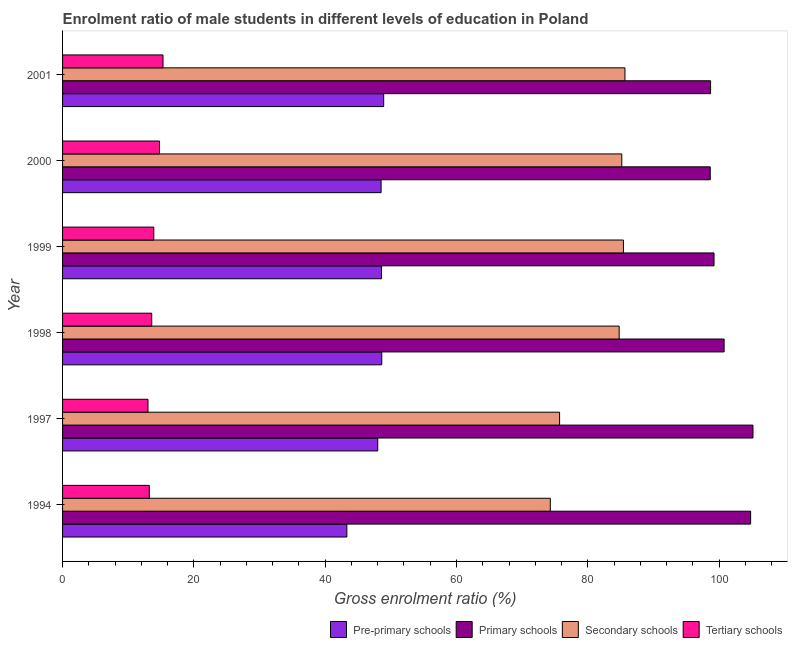How many different coloured bars are there?
Offer a very short reply. 4. How many groups of bars are there?
Your response must be concise. 6. Are the number of bars per tick equal to the number of legend labels?
Provide a short and direct response. Yes. How many bars are there on the 1st tick from the top?
Your answer should be very brief. 4. In how many cases, is the number of bars for a given year not equal to the number of legend labels?
Your answer should be very brief. 0. What is the gross enrolment ratio(female) in tertiary schools in 1998?
Provide a short and direct response. 13.58. Across all years, what is the maximum gross enrolment ratio(female) in tertiary schools?
Keep it short and to the point. 15.3. Across all years, what is the minimum gross enrolment ratio(female) in tertiary schools?
Provide a succinct answer. 13.01. What is the total gross enrolment ratio(female) in secondary schools in the graph?
Offer a very short reply. 491.03. What is the difference between the gross enrolment ratio(female) in primary schools in 2000 and that in 2001?
Offer a terse response. -0.05. What is the difference between the gross enrolment ratio(female) in tertiary schools in 1997 and the gross enrolment ratio(female) in secondary schools in 1994?
Keep it short and to the point. -61.28. What is the average gross enrolment ratio(female) in primary schools per year?
Offer a terse response. 101.22. In the year 2001, what is the difference between the gross enrolment ratio(female) in pre-primary schools and gross enrolment ratio(female) in tertiary schools?
Ensure brevity in your answer.  33.61. Is the difference between the gross enrolment ratio(female) in pre-primary schools in 1999 and 2000 greater than the difference between the gross enrolment ratio(female) in secondary schools in 1999 and 2000?
Offer a terse response. No. What is the difference between the highest and the second highest gross enrolment ratio(female) in pre-primary schools?
Your response must be concise. 0.29. What is the difference between the highest and the lowest gross enrolment ratio(female) in secondary schools?
Provide a succinct answer. 11.37. In how many years, is the gross enrolment ratio(female) in pre-primary schools greater than the average gross enrolment ratio(female) in pre-primary schools taken over all years?
Provide a succinct answer. 5. Is the sum of the gross enrolment ratio(female) in tertiary schools in 1994 and 1999 greater than the maximum gross enrolment ratio(female) in pre-primary schools across all years?
Offer a very short reply. No. Is it the case that in every year, the sum of the gross enrolment ratio(female) in tertiary schools and gross enrolment ratio(female) in primary schools is greater than the sum of gross enrolment ratio(female) in pre-primary schools and gross enrolment ratio(female) in secondary schools?
Offer a very short reply. No. What does the 4th bar from the top in 2000 represents?
Provide a succinct answer. Pre-primary schools. What does the 2nd bar from the bottom in 2001 represents?
Give a very brief answer. Primary schools. Where does the legend appear in the graph?
Make the answer very short. Bottom right. How many legend labels are there?
Your answer should be compact. 4. How are the legend labels stacked?
Give a very brief answer. Horizontal. What is the title of the graph?
Provide a short and direct response. Enrolment ratio of male students in different levels of education in Poland. Does "Offering training" appear as one of the legend labels in the graph?
Offer a very short reply. No. What is the label or title of the X-axis?
Make the answer very short. Gross enrolment ratio (%). What is the label or title of the Y-axis?
Offer a terse response. Year. What is the Gross enrolment ratio (%) of Pre-primary schools in 1994?
Offer a very short reply. 43.3. What is the Gross enrolment ratio (%) in Primary schools in 1994?
Make the answer very short. 104.8. What is the Gross enrolment ratio (%) in Secondary schools in 1994?
Offer a terse response. 74.29. What is the Gross enrolment ratio (%) in Tertiary schools in 1994?
Offer a terse response. 13.21. What is the Gross enrolment ratio (%) in Pre-primary schools in 1997?
Your response must be concise. 48. What is the Gross enrolment ratio (%) of Primary schools in 1997?
Make the answer very short. 105.16. What is the Gross enrolment ratio (%) of Secondary schools in 1997?
Give a very brief answer. 75.7. What is the Gross enrolment ratio (%) in Tertiary schools in 1997?
Provide a succinct answer. 13.01. What is the Gross enrolment ratio (%) in Pre-primary schools in 1998?
Your answer should be very brief. 48.62. What is the Gross enrolment ratio (%) in Primary schools in 1998?
Make the answer very short. 100.76. What is the Gross enrolment ratio (%) in Secondary schools in 1998?
Ensure brevity in your answer.  84.78. What is the Gross enrolment ratio (%) of Tertiary schools in 1998?
Ensure brevity in your answer.  13.58. What is the Gross enrolment ratio (%) of Pre-primary schools in 1999?
Offer a terse response. 48.58. What is the Gross enrolment ratio (%) of Primary schools in 1999?
Keep it short and to the point. 99.23. What is the Gross enrolment ratio (%) in Secondary schools in 1999?
Make the answer very short. 85.42. What is the Gross enrolment ratio (%) in Tertiary schools in 1999?
Your answer should be very brief. 13.9. What is the Gross enrolment ratio (%) in Pre-primary schools in 2000?
Your answer should be very brief. 48.52. What is the Gross enrolment ratio (%) of Primary schools in 2000?
Ensure brevity in your answer.  98.65. What is the Gross enrolment ratio (%) in Secondary schools in 2000?
Offer a terse response. 85.17. What is the Gross enrolment ratio (%) in Tertiary schools in 2000?
Your answer should be compact. 14.77. What is the Gross enrolment ratio (%) of Pre-primary schools in 2001?
Make the answer very short. 48.91. What is the Gross enrolment ratio (%) in Primary schools in 2001?
Make the answer very short. 98.7. What is the Gross enrolment ratio (%) of Secondary schools in 2001?
Offer a terse response. 85.66. What is the Gross enrolment ratio (%) in Tertiary schools in 2001?
Your response must be concise. 15.3. Across all years, what is the maximum Gross enrolment ratio (%) of Pre-primary schools?
Provide a succinct answer. 48.91. Across all years, what is the maximum Gross enrolment ratio (%) in Primary schools?
Your answer should be compact. 105.16. Across all years, what is the maximum Gross enrolment ratio (%) of Secondary schools?
Your answer should be very brief. 85.66. Across all years, what is the maximum Gross enrolment ratio (%) of Tertiary schools?
Make the answer very short. 15.3. Across all years, what is the minimum Gross enrolment ratio (%) of Pre-primary schools?
Ensure brevity in your answer.  43.3. Across all years, what is the minimum Gross enrolment ratio (%) in Primary schools?
Provide a succinct answer. 98.65. Across all years, what is the minimum Gross enrolment ratio (%) in Secondary schools?
Ensure brevity in your answer.  74.29. Across all years, what is the minimum Gross enrolment ratio (%) in Tertiary schools?
Ensure brevity in your answer.  13.01. What is the total Gross enrolment ratio (%) in Pre-primary schools in the graph?
Your answer should be compact. 285.93. What is the total Gross enrolment ratio (%) of Primary schools in the graph?
Ensure brevity in your answer.  607.3. What is the total Gross enrolment ratio (%) in Secondary schools in the graph?
Give a very brief answer. 491.03. What is the total Gross enrolment ratio (%) in Tertiary schools in the graph?
Your answer should be very brief. 83.76. What is the difference between the Gross enrolment ratio (%) in Pre-primary schools in 1994 and that in 1997?
Keep it short and to the point. -4.7. What is the difference between the Gross enrolment ratio (%) of Primary schools in 1994 and that in 1997?
Your response must be concise. -0.36. What is the difference between the Gross enrolment ratio (%) of Secondary schools in 1994 and that in 1997?
Give a very brief answer. -1.41. What is the difference between the Gross enrolment ratio (%) of Tertiary schools in 1994 and that in 1997?
Your answer should be very brief. 0.2. What is the difference between the Gross enrolment ratio (%) of Pre-primary schools in 1994 and that in 1998?
Keep it short and to the point. -5.32. What is the difference between the Gross enrolment ratio (%) of Primary schools in 1994 and that in 1998?
Your answer should be compact. 4.04. What is the difference between the Gross enrolment ratio (%) of Secondary schools in 1994 and that in 1998?
Your response must be concise. -10.49. What is the difference between the Gross enrolment ratio (%) in Tertiary schools in 1994 and that in 1998?
Your response must be concise. -0.37. What is the difference between the Gross enrolment ratio (%) of Pre-primary schools in 1994 and that in 1999?
Your response must be concise. -5.28. What is the difference between the Gross enrolment ratio (%) in Primary schools in 1994 and that in 1999?
Your response must be concise. 5.57. What is the difference between the Gross enrolment ratio (%) of Secondary schools in 1994 and that in 1999?
Ensure brevity in your answer.  -11.14. What is the difference between the Gross enrolment ratio (%) in Tertiary schools in 1994 and that in 1999?
Ensure brevity in your answer.  -0.69. What is the difference between the Gross enrolment ratio (%) of Pre-primary schools in 1994 and that in 2000?
Offer a terse response. -5.21. What is the difference between the Gross enrolment ratio (%) of Primary schools in 1994 and that in 2000?
Provide a succinct answer. 6.15. What is the difference between the Gross enrolment ratio (%) of Secondary schools in 1994 and that in 2000?
Your response must be concise. -10.88. What is the difference between the Gross enrolment ratio (%) of Tertiary schools in 1994 and that in 2000?
Provide a succinct answer. -1.56. What is the difference between the Gross enrolment ratio (%) in Pre-primary schools in 1994 and that in 2001?
Your response must be concise. -5.61. What is the difference between the Gross enrolment ratio (%) in Primary schools in 1994 and that in 2001?
Your response must be concise. 6.1. What is the difference between the Gross enrolment ratio (%) in Secondary schools in 1994 and that in 2001?
Make the answer very short. -11.37. What is the difference between the Gross enrolment ratio (%) of Tertiary schools in 1994 and that in 2001?
Provide a short and direct response. -2.09. What is the difference between the Gross enrolment ratio (%) of Pre-primary schools in 1997 and that in 1998?
Your answer should be compact. -0.61. What is the difference between the Gross enrolment ratio (%) in Primary schools in 1997 and that in 1998?
Provide a succinct answer. 4.39. What is the difference between the Gross enrolment ratio (%) in Secondary schools in 1997 and that in 1998?
Your response must be concise. -9.07. What is the difference between the Gross enrolment ratio (%) of Tertiary schools in 1997 and that in 1998?
Make the answer very short. -0.57. What is the difference between the Gross enrolment ratio (%) of Pre-primary schools in 1997 and that in 1999?
Your answer should be compact. -0.58. What is the difference between the Gross enrolment ratio (%) in Primary schools in 1997 and that in 1999?
Your answer should be very brief. 5.93. What is the difference between the Gross enrolment ratio (%) of Secondary schools in 1997 and that in 1999?
Offer a very short reply. -9.72. What is the difference between the Gross enrolment ratio (%) of Tertiary schools in 1997 and that in 1999?
Provide a short and direct response. -0.89. What is the difference between the Gross enrolment ratio (%) of Pre-primary schools in 1997 and that in 2000?
Keep it short and to the point. -0.51. What is the difference between the Gross enrolment ratio (%) of Primary schools in 1997 and that in 2000?
Your answer should be very brief. 6.51. What is the difference between the Gross enrolment ratio (%) of Secondary schools in 1997 and that in 2000?
Provide a succinct answer. -9.47. What is the difference between the Gross enrolment ratio (%) of Tertiary schools in 1997 and that in 2000?
Keep it short and to the point. -1.76. What is the difference between the Gross enrolment ratio (%) of Pre-primary schools in 1997 and that in 2001?
Offer a very short reply. -0.91. What is the difference between the Gross enrolment ratio (%) of Primary schools in 1997 and that in 2001?
Make the answer very short. 6.45. What is the difference between the Gross enrolment ratio (%) of Secondary schools in 1997 and that in 2001?
Your response must be concise. -9.96. What is the difference between the Gross enrolment ratio (%) in Tertiary schools in 1997 and that in 2001?
Your response must be concise. -2.29. What is the difference between the Gross enrolment ratio (%) of Pre-primary schools in 1998 and that in 1999?
Provide a short and direct response. 0.04. What is the difference between the Gross enrolment ratio (%) of Primary schools in 1998 and that in 1999?
Your response must be concise. 1.54. What is the difference between the Gross enrolment ratio (%) of Secondary schools in 1998 and that in 1999?
Ensure brevity in your answer.  -0.65. What is the difference between the Gross enrolment ratio (%) in Tertiary schools in 1998 and that in 1999?
Provide a succinct answer. -0.32. What is the difference between the Gross enrolment ratio (%) of Pre-primary schools in 1998 and that in 2000?
Keep it short and to the point. 0.1. What is the difference between the Gross enrolment ratio (%) in Primary schools in 1998 and that in 2000?
Your response must be concise. 2.11. What is the difference between the Gross enrolment ratio (%) in Secondary schools in 1998 and that in 2000?
Make the answer very short. -0.4. What is the difference between the Gross enrolment ratio (%) of Tertiary schools in 1998 and that in 2000?
Give a very brief answer. -1.19. What is the difference between the Gross enrolment ratio (%) of Pre-primary schools in 1998 and that in 2001?
Offer a terse response. -0.29. What is the difference between the Gross enrolment ratio (%) in Primary schools in 1998 and that in 2001?
Ensure brevity in your answer.  2.06. What is the difference between the Gross enrolment ratio (%) in Secondary schools in 1998 and that in 2001?
Your answer should be very brief. -0.88. What is the difference between the Gross enrolment ratio (%) in Tertiary schools in 1998 and that in 2001?
Give a very brief answer. -1.72. What is the difference between the Gross enrolment ratio (%) in Pre-primary schools in 1999 and that in 2000?
Offer a very short reply. 0.06. What is the difference between the Gross enrolment ratio (%) of Primary schools in 1999 and that in 2000?
Your response must be concise. 0.58. What is the difference between the Gross enrolment ratio (%) in Secondary schools in 1999 and that in 2000?
Offer a very short reply. 0.25. What is the difference between the Gross enrolment ratio (%) in Tertiary schools in 1999 and that in 2000?
Offer a very short reply. -0.87. What is the difference between the Gross enrolment ratio (%) in Pre-primary schools in 1999 and that in 2001?
Give a very brief answer. -0.33. What is the difference between the Gross enrolment ratio (%) in Primary schools in 1999 and that in 2001?
Keep it short and to the point. 0.52. What is the difference between the Gross enrolment ratio (%) of Secondary schools in 1999 and that in 2001?
Make the answer very short. -0.23. What is the difference between the Gross enrolment ratio (%) in Tertiary schools in 1999 and that in 2001?
Keep it short and to the point. -1.4. What is the difference between the Gross enrolment ratio (%) of Pre-primary schools in 2000 and that in 2001?
Provide a short and direct response. -0.39. What is the difference between the Gross enrolment ratio (%) in Primary schools in 2000 and that in 2001?
Your answer should be compact. -0.05. What is the difference between the Gross enrolment ratio (%) of Secondary schools in 2000 and that in 2001?
Make the answer very short. -0.48. What is the difference between the Gross enrolment ratio (%) of Tertiary schools in 2000 and that in 2001?
Make the answer very short. -0.53. What is the difference between the Gross enrolment ratio (%) of Pre-primary schools in 1994 and the Gross enrolment ratio (%) of Primary schools in 1997?
Your answer should be very brief. -61.86. What is the difference between the Gross enrolment ratio (%) in Pre-primary schools in 1994 and the Gross enrolment ratio (%) in Secondary schools in 1997?
Ensure brevity in your answer.  -32.4. What is the difference between the Gross enrolment ratio (%) in Pre-primary schools in 1994 and the Gross enrolment ratio (%) in Tertiary schools in 1997?
Offer a very short reply. 30.29. What is the difference between the Gross enrolment ratio (%) of Primary schools in 1994 and the Gross enrolment ratio (%) of Secondary schools in 1997?
Your answer should be very brief. 29.1. What is the difference between the Gross enrolment ratio (%) of Primary schools in 1994 and the Gross enrolment ratio (%) of Tertiary schools in 1997?
Your answer should be very brief. 91.79. What is the difference between the Gross enrolment ratio (%) of Secondary schools in 1994 and the Gross enrolment ratio (%) of Tertiary schools in 1997?
Your response must be concise. 61.28. What is the difference between the Gross enrolment ratio (%) of Pre-primary schools in 1994 and the Gross enrolment ratio (%) of Primary schools in 1998?
Ensure brevity in your answer.  -57.46. What is the difference between the Gross enrolment ratio (%) in Pre-primary schools in 1994 and the Gross enrolment ratio (%) in Secondary schools in 1998?
Your answer should be very brief. -41.48. What is the difference between the Gross enrolment ratio (%) of Pre-primary schools in 1994 and the Gross enrolment ratio (%) of Tertiary schools in 1998?
Ensure brevity in your answer.  29.72. What is the difference between the Gross enrolment ratio (%) of Primary schools in 1994 and the Gross enrolment ratio (%) of Secondary schools in 1998?
Keep it short and to the point. 20.02. What is the difference between the Gross enrolment ratio (%) in Primary schools in 1994 and the Gross enrolment ratio (%) in Tertiary schools in 1998?
Make the answer very short. 91.22. What is the difference between the Gross enrolment ratio (%) in Secondary schools in 1994 and the Gross enrolment ratio (%) in Tertiary schools in 1998?
Offer a terse response. 60.71. What is the difference between the Gross enrolment ratio (%) of Pre-primary schools in 1994 and the Gross enrolment ratio (%) of Primary schools in 1999?
Offer a very short reply. -55.92. What is the difference between the Gross enrolment ratio (%) in Pre-primary schools in 1994 and the Gross enrolment ratio (%) in Secondary schools in 1999?
Provide a succinct answer. -42.12. What is the difference between the Gross enrolment ratio (%) in Pre-primary schools in 1994 and the Gross enrolment ratio (%) in Tertiary schools in 1999?
Ensure brevity in your answer.  29.4. What is the difference between the Gross enrolment ratio (%) of Primary schools in 1994 and the Gross enrolment ratio (%) of Secondary schools in 1999?
Your answer should be very brief. 19.38. What is the difference between the Gross enrolment ratio (%) of Primary schools in 1994 and the Gross enrolment ratio (%) of Tertiary schools in 1999?
Make the answer very short. 90.9. What is the difference between the Gross enrolment ratio (%) in Secondary schools in 1994 and the Gross enrolment ratio (%) in Tertiary schools in 1999?
Provide a succinct answer. 60.39. What is the difference between the Gross enrolment ratio (%) in Pre-primary schools in 1994 and the Gross enrolment ratio (%) in Primary schools in 2000?
Ensure brevity in your answer.  -55.35. What is the difference between the Gross enrolment ratio (%) of Pre-primary schools in 1994 and the Gross enrolment ratio (%) of Secondary schools in 2000?
Your answer should be compact. -41.87. What is the difference between the Gross enrolment ratio (%) in Pre-primary schools in 1994 and the Gross enrolment ratio (%) in Tertiary schools in 2000?
Offer a very short reply. 28.53. What is the difference between the Gross enrolment ratio (%) of Primary schools in 1994 and the Gross enrolment ratio (%) of Secondary schools in 2000?
Offer a terse response. 19.63. What is the difference between the Gross enrolment ratio (%) in Primary schools in 1994 and the Gross enrolment ratio (%) in Tertiary schools in 2000?
Keep it short and to the point. 90.03. What is the difference between the Gross enrolment ratio (%) of Secondary schools in 1994 and the Gross enrolment ratio (%) of Tertiary schools in 2000?
Provide a short and direct response. 59.52. What is the difference between the Gross enrolment ratio (%) of Pre-primary schools in 1994 and the Gross enrolment ratio (%) of Primary schools in 2001?
Keep it short and to the point. -55.4. What is the difference between the Gross enrolment ratio (%) of Pre-primary schools in 1994 and the Gross enrolment ratio (%) of Secondary schools in 2001?
Your answer should be compact. -42.36. What is the difference between the Gross enrolment ratio (%) in Pre-primary schools in 1994 and the Gross enrolment ratio (%) in Tertiary schools in 2001?
Give a very brief answer. 28. What is the difference between the Gross enrolment ratio (%) of Primary schools in 1994 and the Gross enrolment ratio (%) of Secondary schools in 2001?
Ensure brevity in your answer.  19.14. What is the difference between the Gross enrolment ratio (%) of Primary schools in 1994 and the Gross enrolment ratio (%) of Tertiary schools in 2001?
Offer a terse response. 89.5. What is the difference between the Gross enrolment ratio (%) in Secondary schools in 1994 and the Gross enrolment ratio (%) in Tertiary schools in 2001?
Make the answer very short. 58.99. What is the difference between the Gross enrolment ratio (%) in Pre-primary schools in 1997 and the Gross enrolment ratio (%) in Primary schools in 1998?
Your response must be concise. -52.76. What is the difference between the Gross enrolment ratio (%) of Pre-primary schools in 1997 and the Gross enrolment ratio (%) of Secondary schools in 1998?
Your answer should be very brief. -36.77. What is the difference between the Gross enrolment ratio (%) in Pre-primary schools in 1997 and the Gross enrolment ratio (%) in Tertiary schools in 1998?
Offer a very short reply. 34.42. What is the difference between the Gross enrolment ratio (%) in Primary schools in 1997 and the Gross enrolment ratio (%) in Secondary schools in 1998?
Give a very brief answer. 20.38. What is the difference between the Gross enrolment ratio (%) of Primary schools in 1997 and the Gross enrolment ratio (%) of Tertiary schools in 1998?
Your answer should be very brief. 91.58. What is the difference between the Gross enrolment ratio (%) in Secondary schools in 1997 and the Gross enrolment ratio (%) in Tertiary schools in 1998?
Keep it short and to the point. 62.12. What is the difference between the Gross enrolment ratio (%) of Pre-primary schools in 1997 and the Gross enrolment ratio (%) of Primary schools in 1999?
Ensure brevity in your answer.  -51.22. What is the difference between the Gross enrolment ratio (%) in Pre-primary schools in 1997 and the Gross enrolment ratio (%) in Secondary schools in 1999?
Your response must be concise. -37.42. What is the difference between the Gross enrolment ratio (%) of Pre-primary schools in 1997 and the Gross enrolment ratio (%) of Tertiary schools in 1999?
Provide a succinct answer. 34.11. What is the difference between the Gross enrolment ratio (%) of Primary schools in 1997 and the Gross enrolment ratio (%) of Secondary schools in 1999?
Provide a short and direct response. 19.73. What is the difference between the Gross enrolment ratio (%) of Primary schools in 1997 and the Gross enrolment ratio (%) of Tertiary schools in 1999?
Offer a terse response. 91.26. What is the difference between the Gross enrolment ratio (%) in Secondary schools in 1997 and the Gross enrolment ratio (%) in Tertiary schools in 1999?
Your response must be concise. 61.8. What is the difference between the Gross enrolment ratio (%) of Pre-primary schools in 1997 and the Gross enrolment ratio (%) of Primary schools in 2000?
Provide a succinct answer. -50.65. What is the difference between the Gross enrolment ratio (%) of Pre-primary schools in 1997 and the Gross enrolment ratio (%) of Secondary schools in 2000?
Offer a terse response. -37.17. What is the difference between the Gross enrolment ratio (%) of Pre-primary schools in 1997 and the Gross enrolment ratio (%) of Tertiary schools in 2000?
Ensure brevity in your answer.  33.24. What is the difference between the Gross enrolment ratio (%) of Primary schools in 1997 and the Gross enrolment ratio (%) of Secondary schools in 2000?
Provide a short and direct response. 19.98. What is the difference between the Gross enrolment ratio (%) of Primary schools in 1997 and the Gross enrolment ratio (%) of Tertiary schools in 2000?
Make the answer very short. 90.39. What is the difference between the Gross enrolment ratio (%) in Secondary schools in 1997 and the Gross enrolment ratio (%) in Tertiary schools in 2000?
Provide a short and direct response. 60.94. What is the difference between the Gross enrolment ratio (%) of Pre-primary schools in 1997 and the Gross enrolment ratio (%) of Primary schools in 2001?
Ensure brevity in your answer.  -50.7. What is the difference between the Gross enrolment ratio (%) in Pre-primary schools in 1997 and the Gross enrolment ratio (%) in Secondary schools in 2001?
Keep it short and to the point. -37.65. What is the difference between the Gross enrolment ratio (%) of Pre-primary schools in 1997 and the Gross enrolment ratio (%) of Tertiary schools in 2001?
Your response must be concise. 32.7. What is the difference between the Gross enrolment ratio (%) in Primary schools in 1997 and the Gross enrolment ratio (%) in Secondary schools in 2001?
Keep it short and to the point. 19.5. What is the difference between the Gross enrolment ratio (%) of Primary schools in 1997 and the Gross enrolment ratio (%) of Tertiary schools in 2001?
Provide a short and direct response. 89.86. What is the difference between the Gross enrolment ratio (%) of Secondary schools in 1997 and the Gross enrolment ratio (%) of Tertiary schools in 2001?
Your answer should be very brief. 60.4. What is the difference between the Gross enrolment ratio (%) in Pre-primary schools in 1998 and the Gross enrolment ratio (%) in Primary schools in 1999?
Your answer should be compact. -50.61. What is the difference between the Gross enrolment ratio (%) of Pre-primary schools in 1998 and the Gross enrolment ratio (%) of Secondary schools in 1999?
Your response must be concise. -36.81. What is the difference between the Gross enrolment ratio (%) in Pre-primary schools in 1998 and the Gross enrolment ratio (%) in Tertiary schools in 1999?
Keep it short and to the point. 34.72. What is the difference between the Gross enrolment ratio (%) of Primary schools in 1998 and the Gross enrolment ratio (%) of Secondary schools in 1999?
Your answer should be very brief. 15.34. What is the difference between the Gross enrolment ratio (%) in Primary schools in 1998 and the Gross enrolment ratio (%) in Tertiary schools in 1999?
Give a very brief answer. 86.87. What is the difference between the Gross enrolment ratio (%) in Secondary schools in 1998 and the Gross enrolment ratio (%) in Tertiary schools in 1999?
Offer a terse response. 70.88. What is the difference between the Gross enrolment ratio (%) in Pre-primary schools in 1998 and the Gross enrolment ratio (%) in Primary schools in 2000?
Your answer should be compact. -50.03. What is the difference between the Gross enrolment ratio (%) of Pre-primary schools in 1998 and the Gross enrolment ratio (%) of Secondary schools in 2000?
Provide a succinct answer. -36.56. What is the difference between the Gross enrolment ratio (%) of Pre-primary schools in 1998 and the Gross enrolment ratio (%) of Tertiary schools in 2000?
Offer a terse response. 33.85. What is the difference between the Gross enrolment ratio (%) in Primary schools in 1998 and the Gross enrolment ratio (%) in Secondary schools in 2000?
Ensure brevity in your answer.  15.59. What is the difference between the Gross enrolment ratio (%) of Primary schools in 1998 and the Gross enrolment ratio (%) of Tertiary schools in 2000?
Provide a succinct answer. 86. What is the difference between the Gross enrolment ratio (%) in Secondary schools in 1998 and the Gross enrolment ratio (%) in Tertiary schools in 2000?
Keep it short and to the point. 70.01. What is the difference between the Gross enrolment ratio (%) of Pre-primary schools in 1998 and the Gross enrolment ratio (%) of Primary schools in 2001?
Provide a short and direct response. -50.08. What is the difference between the Gross enrolment ratio (%) in Pre-primary schools in 1998 and the Gross enrolment ratio (%) in Secondary schools in 2001?
Your response must be concise. -37.04. What is the difference between the Gross enrolment ratio (%) of Pre-primary schools in 1998 and the Gross enrolment ratio (%) of Tertiary schools in 2001?
Your answer should be very brief. 33.32. What is the difference between the Gross enrolment ratio (%) in Primary schools in 1998 and the Gross enrolment ratio (%) in Secondary schools in 2001?
Your answer should be compact. 15.1. What is the difference between the Gross enrolment ratio (%) in Primary schools in 1998 and the Gross enrolment ratio (%) in Tertiary schools in 2001?
Your response must be concise. 85.46. What is the difference between the Gross enrolment ratio (%) of Secondary schools in 1998 and the Gross enrolment ratio (%) of Tertiary schools in 2001?
Your answer should be compact. 69.48. What is the difference between the Gross enrolment ratio (%) of Pre-primary schools in 1999 and the Gross enrolment ratio (%) of Primary schools in 2000?
Offer a very short reply. -50.07. What is the difference between the Gross enrolment ratio (%) of Pre-primary schools in 1999 and the Gross enrolment ratio (%) of Secondary schools in 2000?
Make the answer very short. -36.59. What is the difference between the Gross enrolment ratio (%) in Pre-primary schools in 1999 and the Gross enrolment ratio (%) in Tertiary schools in 2000?
Offer a very short reply. 33.81. What is the difference between the Gross enrolment ratio (%) of Primary schools in 1999 and the Gross enrolment ratio (%) of Secondary schools in 2000?
Your response must be concise. 14.05. What is the difference between the Gross enrolment ratio (%) of Primary schools in 1999 and the Gross enrolment ratio (%) of Tertiary schools in 2000?
Make the answer very short. 84.46. What is the difference between the Gross enrolment ratio (%) in Secondary schools in 1999 and the Gross enrolment ratio (%) in Tertiary schools in 2000?
Your answer should be very brief. 70.66. What is the difference between the Gross enrolment ratio (%) in Pre-primary schools in 1999 and the Gross enrolment ratio (%) in Primary schools in 2001?
Offer a very short reply. -50.12. What is the difference between the Gross enrolment ratio (%) of Pre-primary schools in 1999 and the Gross enrolment ratio (%) of Secondary schools in 2001?
Provide a succinct answer. -37.08. What is the difference between the Gross enrolment ratio (%) of Pre-primary schools in 1999 and the Gross enrolment ratio (%) of Tertiary schools in 2001?
Your answer should be compact. 33.28. What is the difference between the Gross enrolment ratio (%) in Primary schools in 1999 and the Gross enrolment ratio (%) in Secondary schools in 2001?
Make the answer very short. 13.57. What is the difference between the Gross enrolment ratio (%) of Primary schools in 1999 and the Gross enrolment ratio (%) of Tertiary schools in 2001?
Give a very brief answer. 83.93. What is the difference between the Gross enrolment ratio (%) in Secondary schools in 1999 and the Gross enrolment ratio (%) in Tertiary schools in 2001?
Your answer should be compact. 70.13. What is the difference between the Gross enrolment ratio (%) in Pre-primary schools in 2000 and the Gross enrolment ratio (%) in Primary schools in 2001?
Your answer should be very brief. -50.19. What is the difference between the Gross enrolment ratio (%) in Pre-primary schools in 2000 and the Gross enrolment ratio (%) in Secondary schools in 2001?
Your answer should be compact. -37.14. What is the difference between the Gross enrolment ratio (%) in Pre-primary schools in 2000 and the Gross enrolment ratio (%) in Tertiary schools in 2001?
Make the answer very short. 33.22. What is the difference between the Gross enrolment ratio (%) in Primary schools in 2000 and the Gross enrolment ratio (%) in Secondary schools in 2001?
Your answer should be very brief. 12.99. What is the difference between the Gross enrolment ratio (%) of Primary schools in 2000 and the Gross enrolment ratio (%) of Tertiary schools in 2001?
Your response must be concise. 83.35. What is the difference between the Gross enrolment ratio (%) of Secondary schools in 2000 and the Gross enrolment ratio (%) of Tertiary schools in 2001?
Your answer should be compact. 69.88. What is the average Gross enrolment ratio (%) in Pre-primary schools per year?
Keep it short and to the point. 47.65. What is the average Gross enrolment ratio (%) of Primary schools per year?
Provide a short and direct response. 101.22. What is the average Gross enrolment ratio (%) in Secondary schools per year?
Give a very brief answer. 81.84. What is the average Gross enrolment ratio (%) in Tertiary schools per year?
Keep it short and to the point. 13.96. In the year 1994, what is the difference between the Gross enrolment ratio (%) in Pre-primary schools and Gross enrolment ratio (%) in Primary schools?
Your response must be concise. -61.5. In the year 1994, what is the difference between the Gross enrolment ratio (%) in Pre-primary schools and Gross enrolment ratio (%) in Secondary schools?
Provide a succinct answer. -30.99. In the year 1994, what is the difference between the Gross enrolment ratio (%) of Pre-primary schools and Gross enrolment ratio (%) of Tertiary schools?
Your answer should be very brief. 30.09. In the year 1994, what is the difference between the Gross enrolment ratio (%) in Primary schools and Gross enrolment ratio (%) in Secondary schools?
Your response must be concise. 30.51. In the year 1994, what is the difference between the Gross enrolment ratio (%) in Primary schools and Gross enrolment ratio (%) in Tertiary schools?
Offer a terse response. 91.59. In the year 1994, what is the difference between the Gross enrolment ratio (%) in Secondary schools and Gross enrolment ratio (%) in Tertiary schools?
Your answer should be very brief. 61.08. In the year 1997, what is the difference between the Gross enrolment ratio (%) in Pre-primary schools and Gross enrolment ratio (%) in Primary schools?
Offer a terse response. -57.15. In the year 1997, what is the difference between the Gross enrolment ratio (%) in Pre-primary schools and Gross enrolment ratio (%) in Secondary schools?
Keep it short and to the point. -27.7. In the year 1997, what is the difference between the Gross enrolment ratio (%) of Pre-primary schools and Gross enrolment ratio (%) of Tertiary schools?
Your answer should be very brief. 34.99. In the year 1997, what is the difference between the Gross enrolment ratio (%) of Primary schools and Gross enrolment ratio (%) of Secondary schools?
Keep it short and to the point. 29.45. In the year 1997, what is the difference between the Gross enrolment ratio (%) in Primary schools and Gross enrolment ratio (%) in Tertiary schools?
Your answer should be compact. 92.15. In the year 1997, what is the difference between the Gross enrolment ratio (%) in Secondary schools and Gross enrolment ratio (%) in Tertiary schools?
Offer a very short reply. 62.69. In the year 1998, what is the difference between the Gross enrolment ratio (%) of Pre-primary schools and Gross enrolment ratio (%) of Primary schools?
Give a very brief answer. -52.15. In the year 1998, what is the difference between the Gross enrolment ratio (%) in Pre-primary schools and Gross enrolment ratio (%) in Secondary schools?
Provide a short and direct response. -36.16. In the year 1998, what is the difference between the Gross enrolment ratio (%) in Pre-primary schools and Gross enrolment ratio (%) in Tertiary schools?
Your answer should be compact. 35.04. In the year 1998, what is the difference between the Gross enrolment ratio (%) of Primary schools and Gross enrolment ratio (%) of Secondary schools?
Provide a succinct answer. 15.99. In the year 1998, what is the difference between the Gross enrolment ratio (%) of Primary schools and Gross enrolment ratio (%) of Tertiary schools?
Make the answer very short. 87.18. In the year 1998, what is the difference between the Gross enrolment ratio (%) in Secondary schools and Gross enrolment ratio (%) in Tertiary schools?
Your answer should be very brief. 71.2. In the year 1999, what is the difference between the Gross enrolment ratio (%) in Pre-primary schools and Gross enrolment ratio (%) in Primary schools?
Provide a succinct answer. -50.65. In the year 1999, what is the difference between the Gross enrolment ratio (%) in Pre-primary schools and Gross enrolment ratio (%) in Secondary schools?
Make the answer very short. -36.85. In the year 1999, what is the difference between the Gross enrolment ratio (%) of Pre-primary schools and Gross enrolment ratio (%) of Tertiary schools?
Your response must be concise. 34.68. In the year 1999, what is the difference between the Gross enrolment ratio (%) in Primary schools and Gross enrolment ratio (%) in Secondary schools?
Keep it short and to the point. 13.8. In the year 1999, what is the difference between the Gross enrolment ratio (%) in Primary schools and Gross enrolment ratio (%) in Tertiary schools?
Your response must be concise. 85.33. In the year 1999, what is the difference between the Gross enrolment ratio (%) in Secondary schools and Gross enrolment ratio (%) in Tertiary schools?
Your answer should be compact. 71.53. In the year 2000, what is the difference between the Gross enrolment ratio (%) in Pre-primary schools and Gross enrolment ratio (%) in Primary schools?
Keep it short and to the point. -50.13. In the year 2000, what is the difference between the Gross enrolment ratio (%) in Pre-primary schools and Gross enrolment ratio (%) in Secondary schools?
Provide a short and direct response. -36.66. In the year 2000, what is the difference between the Gross enrolment ratio (%) in Pre-primary schools and Gross enrolment ratio (%) in Tertiary schools?
Make the answer very short. 33.75. In the year 2000, what is the difference between the Gross enrolment ratio (%) of Primary schools and Gross enrolment ratio (%) of Secondary schools?
Your response must be concise. 13.47. In the year 2000, what is the difference between the Gross enrolment ratio (%) in Primary schools and Gross enrolment ratio (%) in Tertiary schools?
Provide a succinct answer. 83.88. In the year 2000, what is the difference between the Gross enrolment ratio (%) in Secondary schools and Gross enrolment ratio (%) in Tertiary schools?
Your answer should be compact. 70.41. In the year 2001, what is the difference between the Gross enrolment ratio (%) in Pre-primary schools and Gross enrolment ratio (%) in Primary schools?
Make the answer very short. -49.79. In the year 2001, what is the difference between the Gross enrolment ratio (%) of Pre-primary schools and Gross enrolment ratio (%) of Secondary schools?
Offer a terse response. -36.75. In the year 2001, what is the difference between the Gross enrolment ratio (%) in Pre-primary schools and Gross enrolment ratio (%) in Tertiary schools?
Give a very brief answer. 33.61. In the year 2001, what is the difference between the Gross enrolment ratio (%) of Primary schools and Gross enrolment ratio (%) of Secondary schools?
Provide a succinct answer. 13.04. In the year 2001, what is the difference between the Gross enrolment ratio (%) of Primary schools and Gross enrolment ratio (%) of Tertiary schools?
Give a very brief answer. 83.4. In the year 2001, what is the difference between the Gross enrolment ratio (%) of Secondary schools and Gross enrolment ratio (%) of Tertiary schools?
Ensure brevity in your answer.  70.36. What is the ratio of the Gross enrolment ratio (%) in Pre-primary schools in 1994 to that in 1997?
Your response must be concise. 0.9. What is the ratio of the Gross enrolment ratio (%) in Primary schools in 1994 to that in 1997?
Make the answer very short. 1. What is the ratio of the Gross enrolment ratio (%) of Secondary schools in 1994 to that in 1997?
Provide a succinct answer. 0.98. What is the ratio of the Gross enrolment ratio (%) of Tertiary schools in 1994 to that in 1997?
Offer a terse response. 1.02. What is the ratio of the Gross enrolment ratio (%) in Pre-primary schools in 1994 to that in 1998?
Provide a short and direct response. 0.89. What is the ratio of the Gross enrolment ratio (%) of Primary schools in 1994 to that in 1998?
Make the answer very short. 1.04. What is the ratio of the Gross enrolment ratio (%) in Secondary schools in 1994 to that in 1998?
Provide a short and direct response. 0.88. What is the ratio of the Gross enrolment ratio (%) in Tertiary schools in 1994 to that in 1998?
Make the answer very short. 0.97. What is the ratio of the Gross enrolment ratio (%) in Pre-primary schools in 1994 to that in 1999?
Keep it short and to the point. 0.89. What is the ratio of the Gross enrolment ratio (%) of Primary schools in 1994 to that in 1999?
Provide a succinct answer. 1.06. What is the ratio of the Gross enrolment ratio (%) of Secondary schools in 1994 to that in 1999?
Your answer should be very brief. 0.87. What is the ratio of the Gross enrolment ratio (%) of Tertiary schools in 1994 to that in 1999?
Make the answer very short. 0.95. What is the ratio of the Gross enrolment ratio (%) in Pre-primary schools in 1994 to that in 2000?
Offer a very short reply. 0.89. What is the ratio of the Gross enrolment ratio (%) in Primary schools in 1994 to that in 2000?
Your answer should be compact. 1.06. What is the ratio of the Gross enrolment ratio (%) of Secondary schools in 1994 to that in 2000?
Provide a succinct answer. 0.87. What is the ratio of the Gross enrolment ratio (%) in Tertiary schools in 1994 to that in 2000?
Give a very brief answer. 0.89. What is the ratio of the Gross enrolment ratio (%) of Pre-primary schools in 1994 to that in 2001?
Ensure brevity in your answer.  0.89. What is the ratio of the Gross enrolment ratio (%) of Primary schools in 1994 to that in 2001?
Your response must be concise. 1.06. What is the ratio of the Gross enrolment ratio (%) of Secondary schools in 1994 to that in 2001?
Your answer should be compact. 0.87. What is the ratio of the Gross enrolment ratio (%) of Tertiary schools in 1994 to that in 2001?
Keep it short and to the point. 0.86. What is the ratio of the Gross enrolment ratio (%) in Pre-primary schools in 1997 to that in 1998?
Your response must be concise. 0.99. What is the ratio of the Gross enrolment ratio (%) of Primary schools in 1997 to that in 1998?
Give a very brief answer. 1.04. What is the ratio of the Gross enrolment ratio (%) of Secondary schools in 1997 to that in 1998?
Offer a terse response. 0.89. What is the ratio of the Gross enrolment ratio (%) of Tertiary schools in 1997 to that in 1998?
Provide a succinct answer. 0.96. What is the ratio of the Gross enrolment ratio (%) of Pre-primary schools in 1997 to that in 1999?
Ensure brevity in your answer.  0.99. What is the ratio of the Gross enrolment ratio (%) in Primary schools in 1997 to that in 1999?
Your answer should be compact. 1.06. What is the ratio of the Gross enrolment ratio (%) in Secondary schools in 1997 to that in 1999?
Your answer should be compact. 0.89. What is the ratio of the Gross enrolment ratio (%) of Tertiary schools in 1997 to that in 1999?
Your response must be concise. 0.94. What is the ratio of the Gross enrolment ratio (%) of Pre-primary schools in 1997 to that in 2000?
Offer a terse response. 0.99. What is the ratio of the Gross enrolment ratio (%) of Primary schools in 1997 to that in 2000?
Your answer should be compact. 1.07. What is the ratio of the Gross enrolment ratio (%) in Secondary schools in 1997 to that in 2000?
Offer a very short reply. 0.89. What is the ratio of the Gross enrolment ratio (%) in Tertiary schools in 1997 to that in 2000?
Provide a short and direct response. 0.88. What is the ratio of the Gross enrolment ratio (%) in Pre-primary schools in 1997 to that in 2001?
Keep it short and to the point. 0.98. What is the ratio of the Gross enrolment ratio (%) in Primary schools in 1997 to that in 2001?
Provide a short and direct response. 1.07. What is the ratio of the Gross enrolment ratio (%) in Secondary schools in 1997 to that in 2001?
Keep it short and to the point. 0.88. What is the ratio of the Gross enrolment ratio (%) in Tertiary schools in 1997 to that in 2001?
Ensure brevity in your answer.  0.85. What is the ratio of the Gross enrolment ratio (%) in Pre-primary schools in 1998 to that in 1999?
Provide a succinct answer. 1. What is the ratio of the Gross enrolment ratio (%) in Primary schools in 1998 to that in 1999?
Keep it short and to the point. 1.02. What is the ratio of the Gross enrolment ratio (%) in Tertiary schools in 1998 to that in 1999?
Provide a succinct answer. 0.98. What is the ratio of the Gross enrolment ratio (%) in Pre-primary schools in 1998 to that in 2000?
Make the answer very short. 1. What is the ratio of the Gross enrolment ratio (%) in Primary schools in 1998 to that in 2000?
Your answer should be very brief. 1.02. What is the ratio of the Gross enrolment ratio (%) in Secondary schools in 1998 to that in 2000?
Provide a short and direct response. 1. What is the ratio of the Gross enrolment ratio (%) in Tertiary schools in 1998 to that in 2000?
Keep it short and to the point. 0.92. What is the ratio of the Gross enrolment ratio (%) of Primary schools in 1998 to that in 2001?
Keep it short and to the point. 1.02. What is the ratio of the Gross enrolment ratio (%) in Secondary schools in 1998 to that in 2001?
Offer a very short reply. 0.99. What is the ratio of the Gross enrolment ratio (%) of Tertiary schools in 1998 to that in 2001?
Provide a succinct answer. 0.89. What is the ratio of the Gross enrolment ratio (%) in Tertiary schools in 1999 to that in 2000?
Ensure brevity in your answer.  0.94. What is the ratio of the Gross enrolment ratio (%) in Pre-primary schools in 1999 to that in 2001?
Your answer should be very brief. 0.99. What is the ratio of the Gross enrolment ratio (%) of Primary schools in 1999 to that in 2001?
Make the answer very short. 1.01. What is the ratio of the Gross enrolment ratio (%) in Tertiary schools in 1999 to that in 2001?
Keep it short and to the point. 0.91. What is the ratio of the Gross enrolment ratio (%) of Pre-primary schools in 2000 to that in 2001?
Provide a short and direct response. 0.99. What is the ratio of the Gross enrolment ratio (%) of Primary schools in 2000 to that in 2001?
Keep it short and to the point. 1. What is the ratio of the Gross enrolment ratio (%) in Secondary schools in 2000 to that in 2001?
Provide a short and direct response. 0.99. What is the ratio of the Gross enrolment ratio (%) in Tertiary schools in 2000 to that in 2001?
Offer a terse response. 0.97. What is the difference between the highest and the second highest Gross enrolment ratio (%) in Pre-primary schools?
Offer a very short reply. 0.29. What is the difference between the highest and the second highest Gross enrolment ratio (%) in Primary schools?
Ensure brevity in your answer.  0.36. What is the difference between the highest and the second highest Gross enrolment ratio (%) of Secondary schools?
Your answer should be compact. 0.23. What is the difference between the highest and the second highest Gross enrolment ratio (%) of Tertiary schools?
Your response must be concise. 0.53. What is the difference between the highest and the lowest Gross enrolment ratio (%) of Pre-primary schools?
Your response must be concise. 5.61. What is the difference between the highest and the lowest Gross enrolment ratio (%) of Primary schools?
Your answer should be compact. 6.51. What is the difference between the highest and the lowest Gross enrolment ratio (%) in Secondary schools?
Make the answer very short. 11.37. What is the difference between the highest and the lowest Gross enrolment ratio (%) in Tertiary schools?
Your response must be concise. 2.29. 